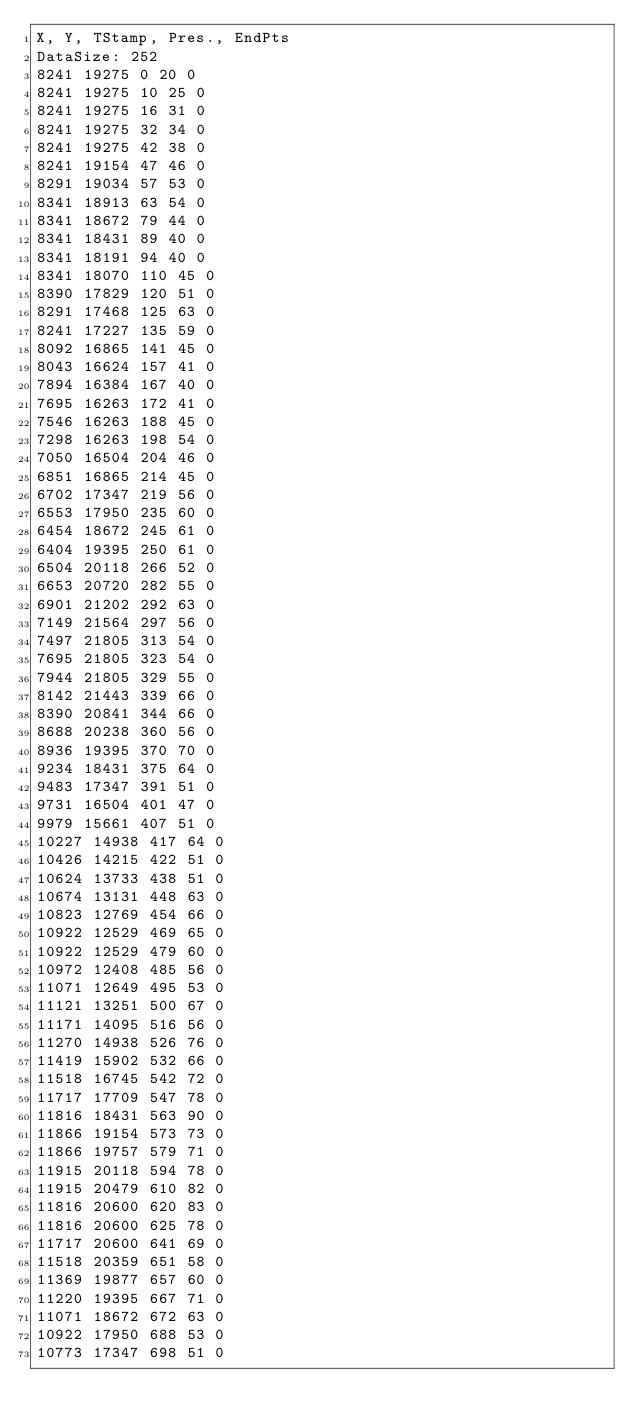Convert code to text. <code><loc_0><loc_0><loc_500><loc_500><_SML_>X, Y, TStamp, Pres., EndPts
DataSize: 252
8241 19275 0 20 0
8241 19275 10 25 0
8241 19275 16 31 0
8241 19275 32 34 0
8241 19275 42 38 0
8241 19154 47 46 0
8291 19034 57 53 0
8341 18913 63 54 0
8341 18672 79 44 0
8341 18431 89 40 0
8341 18191 94 40 0
8341 18070 110 45 0
8390 17829 120 51 0
8291 17468 125 63 0
8241 17227 135 59 0
8092 16865 141 45 0
8043 16624 157 41 0
7894 16384 167 40 0
7695 16263 172 41 0
7546 16263 188 45 0
7298 16263 198 54 0
7050 16504 204 46 0
6851 16865 214 45 0
6702 17347 219 56 0
6553 17950 235 60 0
6454 18672 245 61 0
6404 19395 250 61 0
6504 20118 266 52 0
6653 20720 282 55 0
6901 21202 292 63 0
7149 21564 297 56 0
7497 21805 313 54 0
7695 21805 323 54 0
7944 21805 329 55 0
8142 21443 339 66 0
8390 20841 344 66 0
8688 20238 360 56 0
8936 19395 370 70 0
9234 18431 375 64 0
9483 17347 391 51 0
9731 16504 401 47 0
9979 15661 407 51 0
10227 14938 417 64 0
10426 14215 422 51 0
10624 13733 438 51 0
10674 13131 448 63 0
10823 12769 454 66 0
10922 12529 469 65 0
10922 12529 479 60 0
10972 12408 485 56 0
11071 12649 495 53 0
11121 13251 500 67 0
11171 14095 516 56 0
11270 14938 526 76 0
11419 15902 532 66 0
11518 16745 542 72 0
11717 17709 547 78 0
11816 18431 563 90 0
11866 19154 573 73 0
11866 19757 579 71 0
11915 20118 594 78 0
11915 20479 610 82 0
11816 20600 620 83 0
11816 20600 625 78 0
11717 20600 641 69 0
11518 20359 651 58 0
11369 19877 657 60 0
11220 19395 667 71 0
11071 18672 672 63 0
10922 17950 688 53 0
10773 17347 698 51 0</code> 